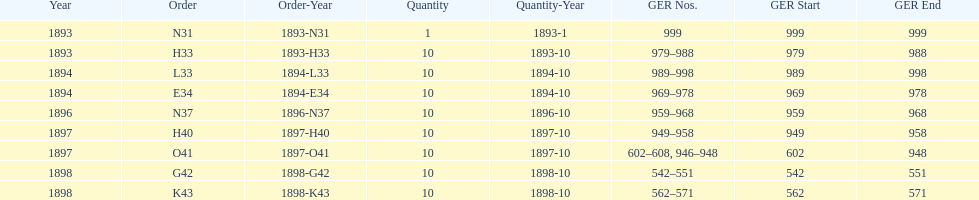Which year had the least ger numbers? 1893. Write the full table. {'header': ['Year', 'Order', 'Order-Year', 'Quantity', 'Quantity-Year', 'GER Nos.', 'GER Start', 'GER End'], 'rows': [['1893', 'N31', '1893-N31', '1', '1893-1', '999', '999', '999'], ['1893', 'H33', '1893-H33', '10', '1893-10', '979–988', '979', '988'], ['1894', 'L33', '1894-L33', '10', '1894-10', '989–998', '989', '998'], ['1894', 'E34', '1894-E34', '10', '1894-10', '969–978', '969', '978'], ['1896', 'N37', '1896-N37', '10', '1896-10', '959–968', '959', '968'], ['1897', 'H40', '1897-H40', '10', '1897-10', '949–958', '949', '958'], ['1897', 'O41', '1897-O41', '10', '1897-10', '602–608, 946–948', '602', '948'], ['1898', 'G42', '1898-G42', '10', '1898-10', '542–551', '542', '551'], ['1898', 'K43', '1898-K43', '10', '1898-10', '562–571', '562', '571']]} 